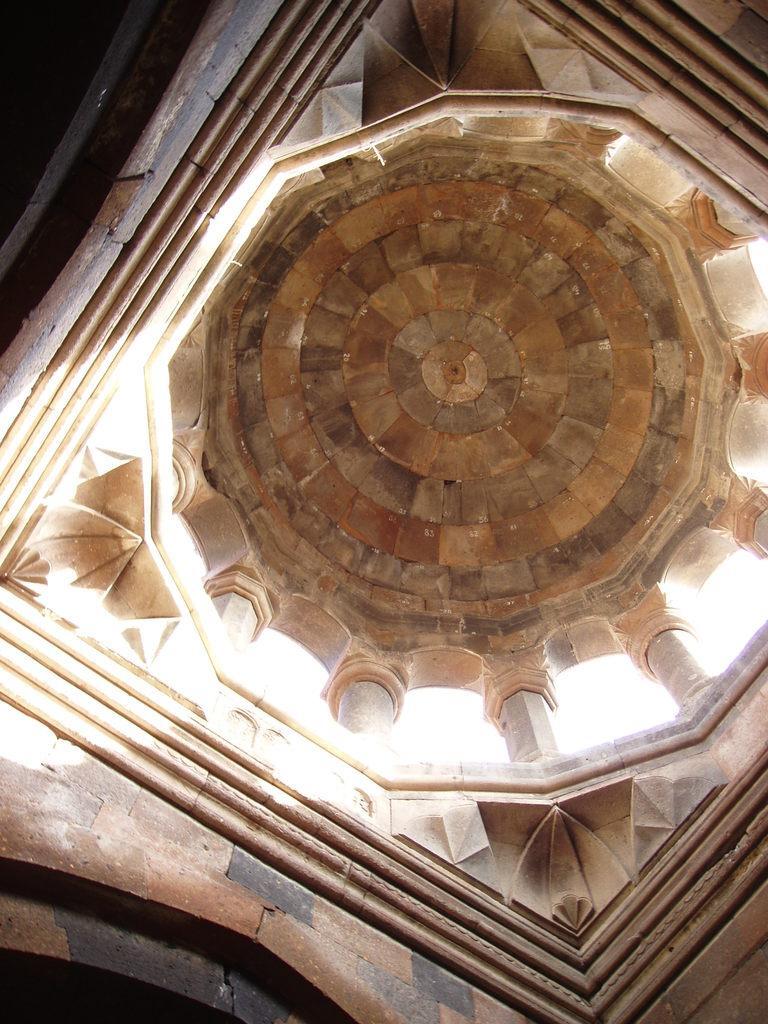Can you describe this image briefly? It is an inside part of a fort. 